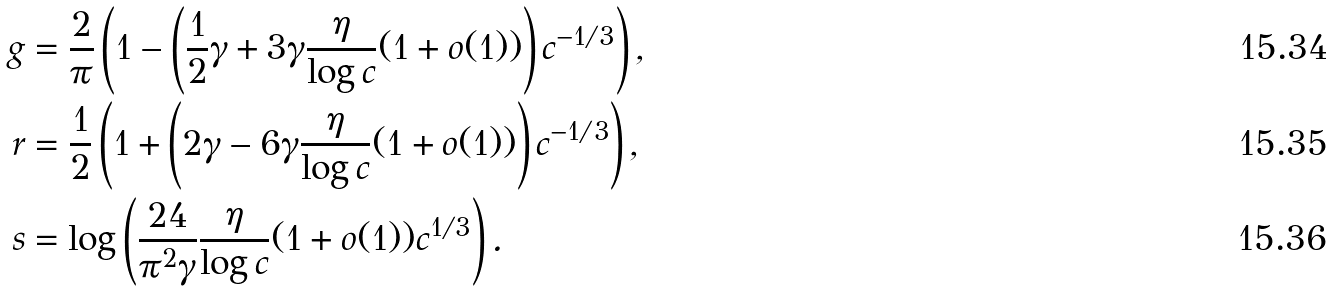<formula> <loc_0><loc_0><loc_500><loc_500>g & = \frac { 2 } { \pi } \left ( 1 - \left ( \frac { 1 } { 2 } \gamma + 3 \gamma \frac { \eta } { \log c } ( 1 + o ( 1 ) ) \right ) c ^ { - 1 / 3 } \right ) , \\ r & = \frac { 1 } { 2 } \left ( 1 + \left ( 2 \gamma - 6 \gamma \frac { \eta } { \log c } ( 1 + o ( 1 ) ) \right ) c ^ { - 1 / 3 } \right ) , \\ s & = \log \left ( \frac { 2 4 } { \pi ^ { 2 } \gamma } \frac { \eta } { \log c } ( 1 + o ( 1 ) ) c ^ { 1 / 3 } \right ) .</formula> 